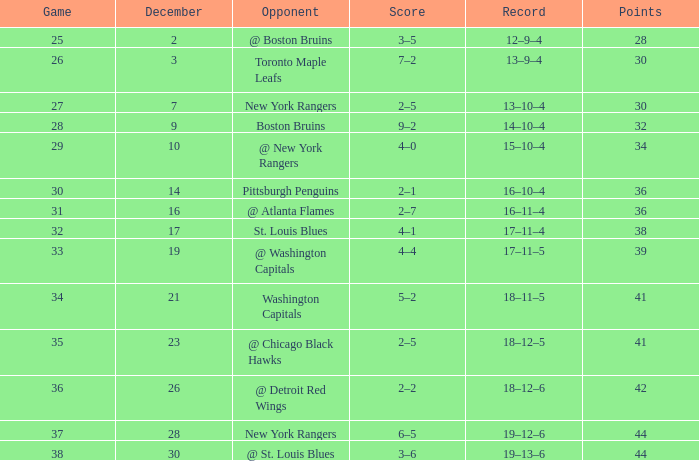Which Game has a Record of 14–10–4, and Points smaller than 32? None. Could you help me parse every detail presented in this table? {'header': ['Game', 'December', 'Opponent', 'Score', 'Record', 'Points'], 'rows': [['25', '2', '@ Boston Bruins', '3–5', '12–9–4', '28'], ['26', '3', 'Toronto Maple Leafs', '7–2', '13–9–4', '30'], ['27', '7', 'New York Rangers', '2–5', '13–10–4', '30'], ['28', '9', 'Boston Bruins', '9–2', '14–10–4', '32'], ['29', '10', '@ New York Rangers', '4–0', '15–10–4', '34'], ['30', '14', 'Pittsburgh Penguins', '2–1', '16–10–4', '36'], ['31', '16', '@ Atlanta Flames', '2–7', '16–11–4', '36'], ['32', '17', 'St. Louis Blues', '4–1', '17–11–4', '38'], ['33', '19', '@ Washington Capitals', '4–4', '17–11–5', '39'], ['34', '21', 'Washington Capitals', '5–2', '18–11–5', '41'], ['35', '23', '@ Chicago Black Hawks', '2–5', '18–12–5', '41'], ['36', '26', '@ Detroit Red Wings', '2–2', '18–12–6', '42'], ['37', '28', 'New York Rangers', '6–5', '19–12–6', '44'], ['38', '30', '@ St. Louis Blues', '3–6', '19–13–6', '44']]} 